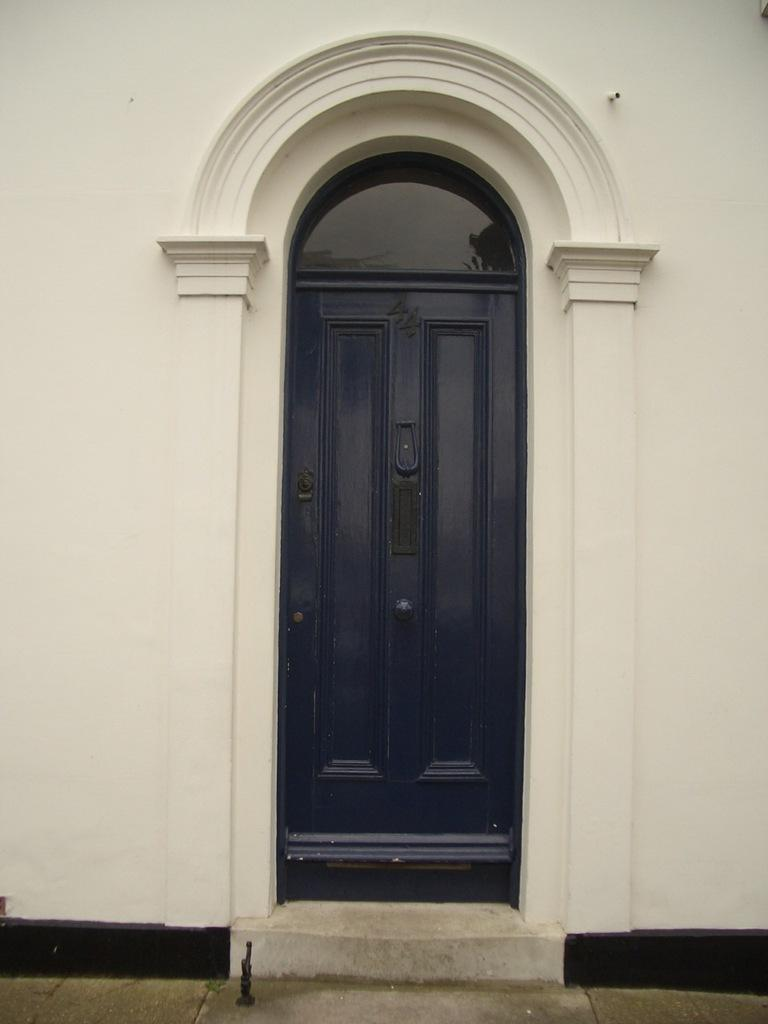What type of structure can be seen in the image? There is a door and a wall in the image. Can you describe the door in the image? The door is a part of the structure visible in the image. What else is present in the image besides the door? There is also a wall in the image. How often does the wire cough in the image? There is no wire present in the image, and therefore no coughing can be observed. 